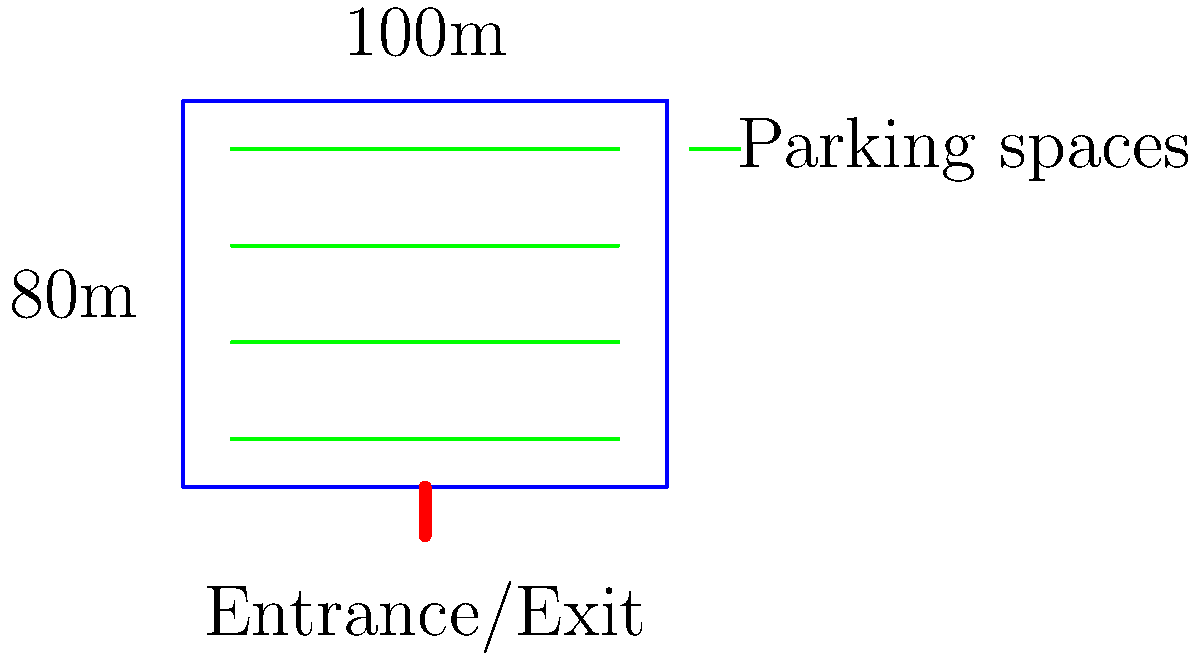You are designing a new truck stop parking layout. The available space is rectangular, measuring 100m by 80m. If each truck parking space requires a width of 5m and a length of 30m, what is the maximum number of trucks that can be parked in this area while maintaining a 10m wide central lane for maneuvering? Let's approach this step-by-step:

1) First, we need to determine how many rows of parking we can fit:
   - The width of the lot is 80m
   - We need a 10m central lane
   - This leaves 70m for parking (80m - 10m = 70m)
   - Each parking space is 5m wide
   - Number of rows = $\frac{70m}{5m} = 14$ rows

2) Now, let's calculate how many trucks can fit in each row:
   - The length of the lot is 100m
   - Each truck needs 30m
   - Number of trucks per row = $\frac{100m}{30m} = 3.33$
   - We can only fit 3 whole trucks per row

3) Calculate the total number of parking spaces:
   - We have 14 rows
   - Each row can fit 3 trucks
   - Total parking spaces = $14 \times 3 = 42$

Therefore, the maximum number of trucks that can be parked in this area while maintaining a 10m wide central lane for maneuvering is 42.
Answer: 42 trucks 